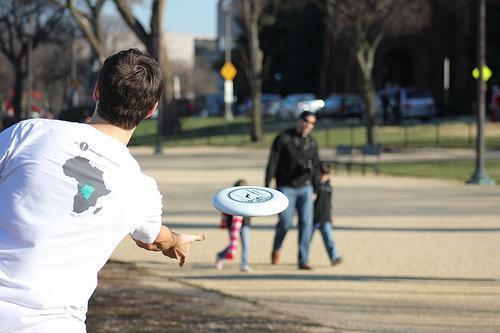How many people are in this picture?
Give a very brief answer. 4. How many children?
Give a very brief answer. 2. How many yellow signs are shown?
Give a very brief answer. 2. 